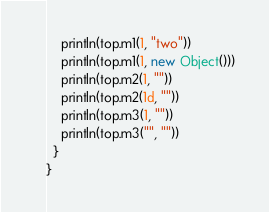<code> <loc_0><loc_0><loc_500><loc_500><_Scala_>    println(top.m1(1, "two"))
    println(top.m1(1, new Object()))
    println(top.m2(1, ""))
    println(top.m2(1d, ""))
    println(top.m3(1, ""))
    println(top.m3("", ""))
  }
}
</code> 